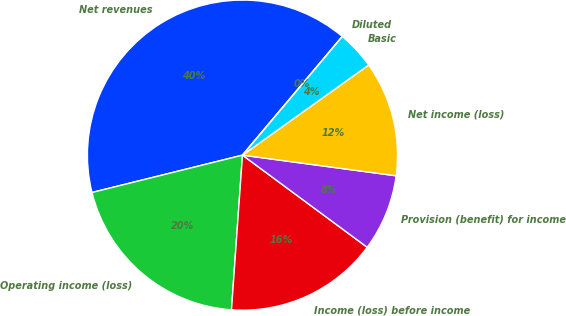<chart> <loc_0><loc_0><loc_500><loc_500><pie_chart><fcel>Net revenues<fcel>Operating income (loss)<fcel>Income (loss) before income<fcel>Provision (benefit) for income<fcel>Net income (loss)<fcel>Basic<fcel>Diluted<nl><fcel>40.0%<fcel>20.0%<fcel>16.0%<fcel>8.0%<fcel>12.0%<fcel>4.0%<fcel>0.0%<nl></chart> 